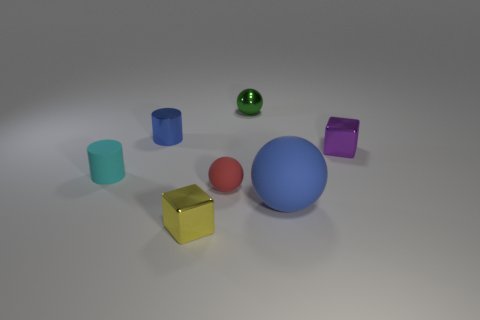Subtract all tiny balls. How many balls are left? 1 Subtract 1 blocks. How many blocks are left? 1 Subtract all green spheres. How many spheres are left? 2 Subtract 1 cyan cylinders. How many objects are left? 6 Subtract all spheres. How many objects are left? 4 Subtract all purple cylinders. Subtract all blue cubes. How many cylinders are left? 2 Subtract all brown spheres. How many green cylinders are left? 0 Subtract all big purple rubber objects. Subtract all small rubber balls. How many objects are left? 6 Add 4 tiny yellow things. How many tiny yellow things are left? 5 Add 4 small metallic blocks. How many small metallic blocks exist? 6 